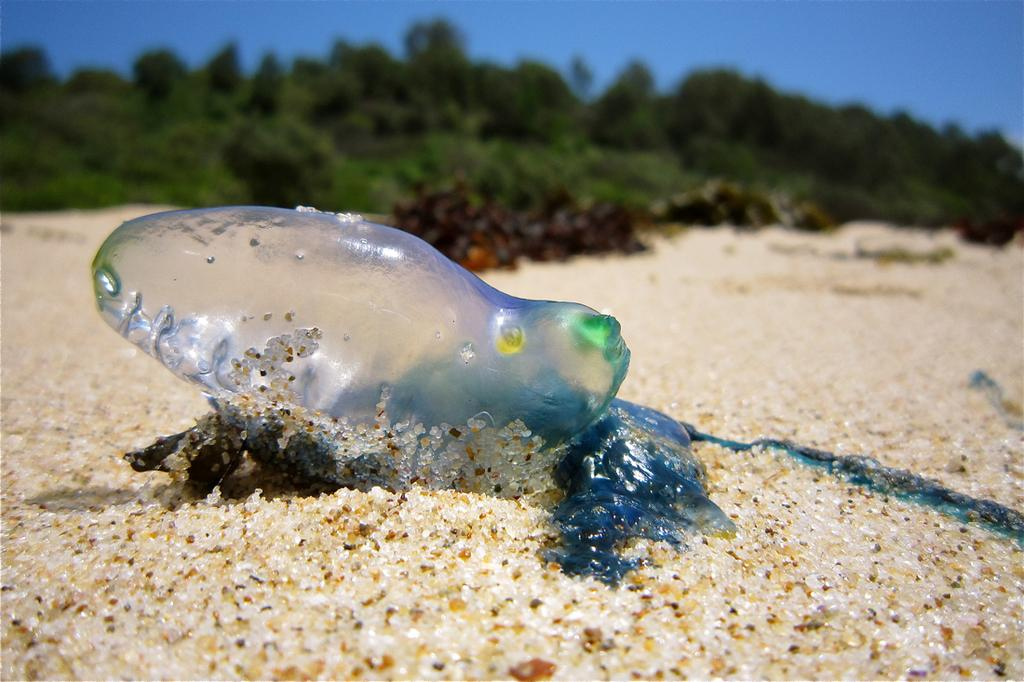What type of animal is in the image? There is a transparent fish in the image. What can be seen at the bottom of the image? There are stones and sand at the bottom of the image. What is visible in the background of the image? There are trees and the sky in the background of the image. How many rabbits are hiding in the trees in the image? There are no rabbits present in the image; it features a transparent fish in a setting with stones, sand, trees, and the sky. 